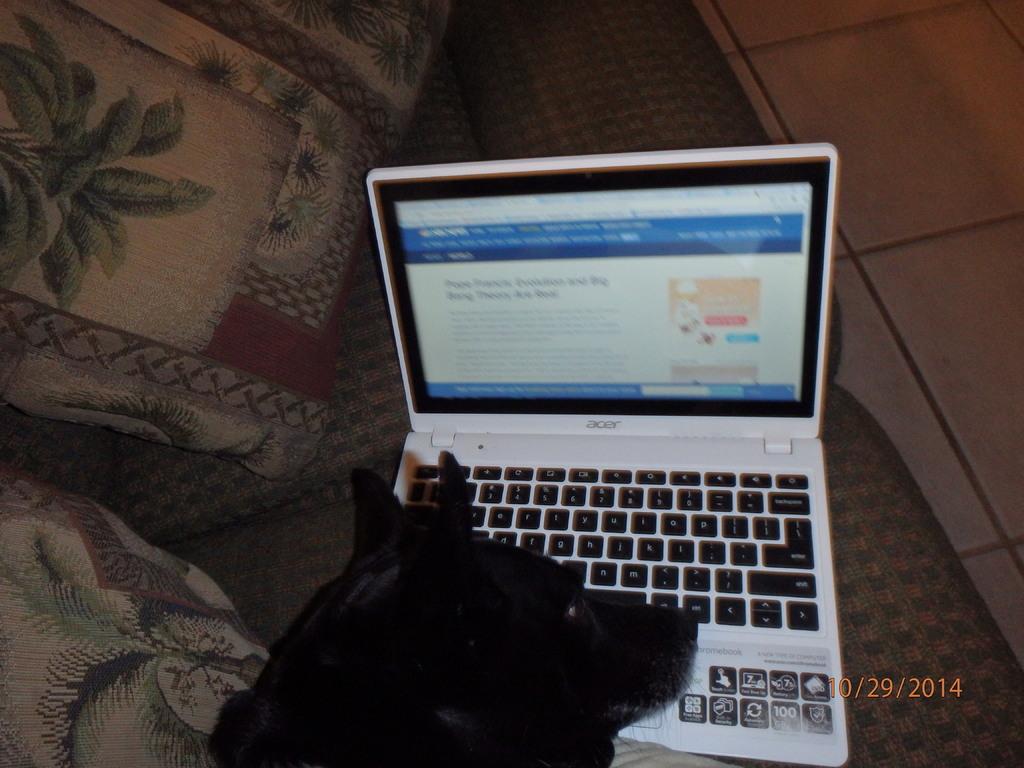What brand is this laptop?
Offer a terse response. Acer. 